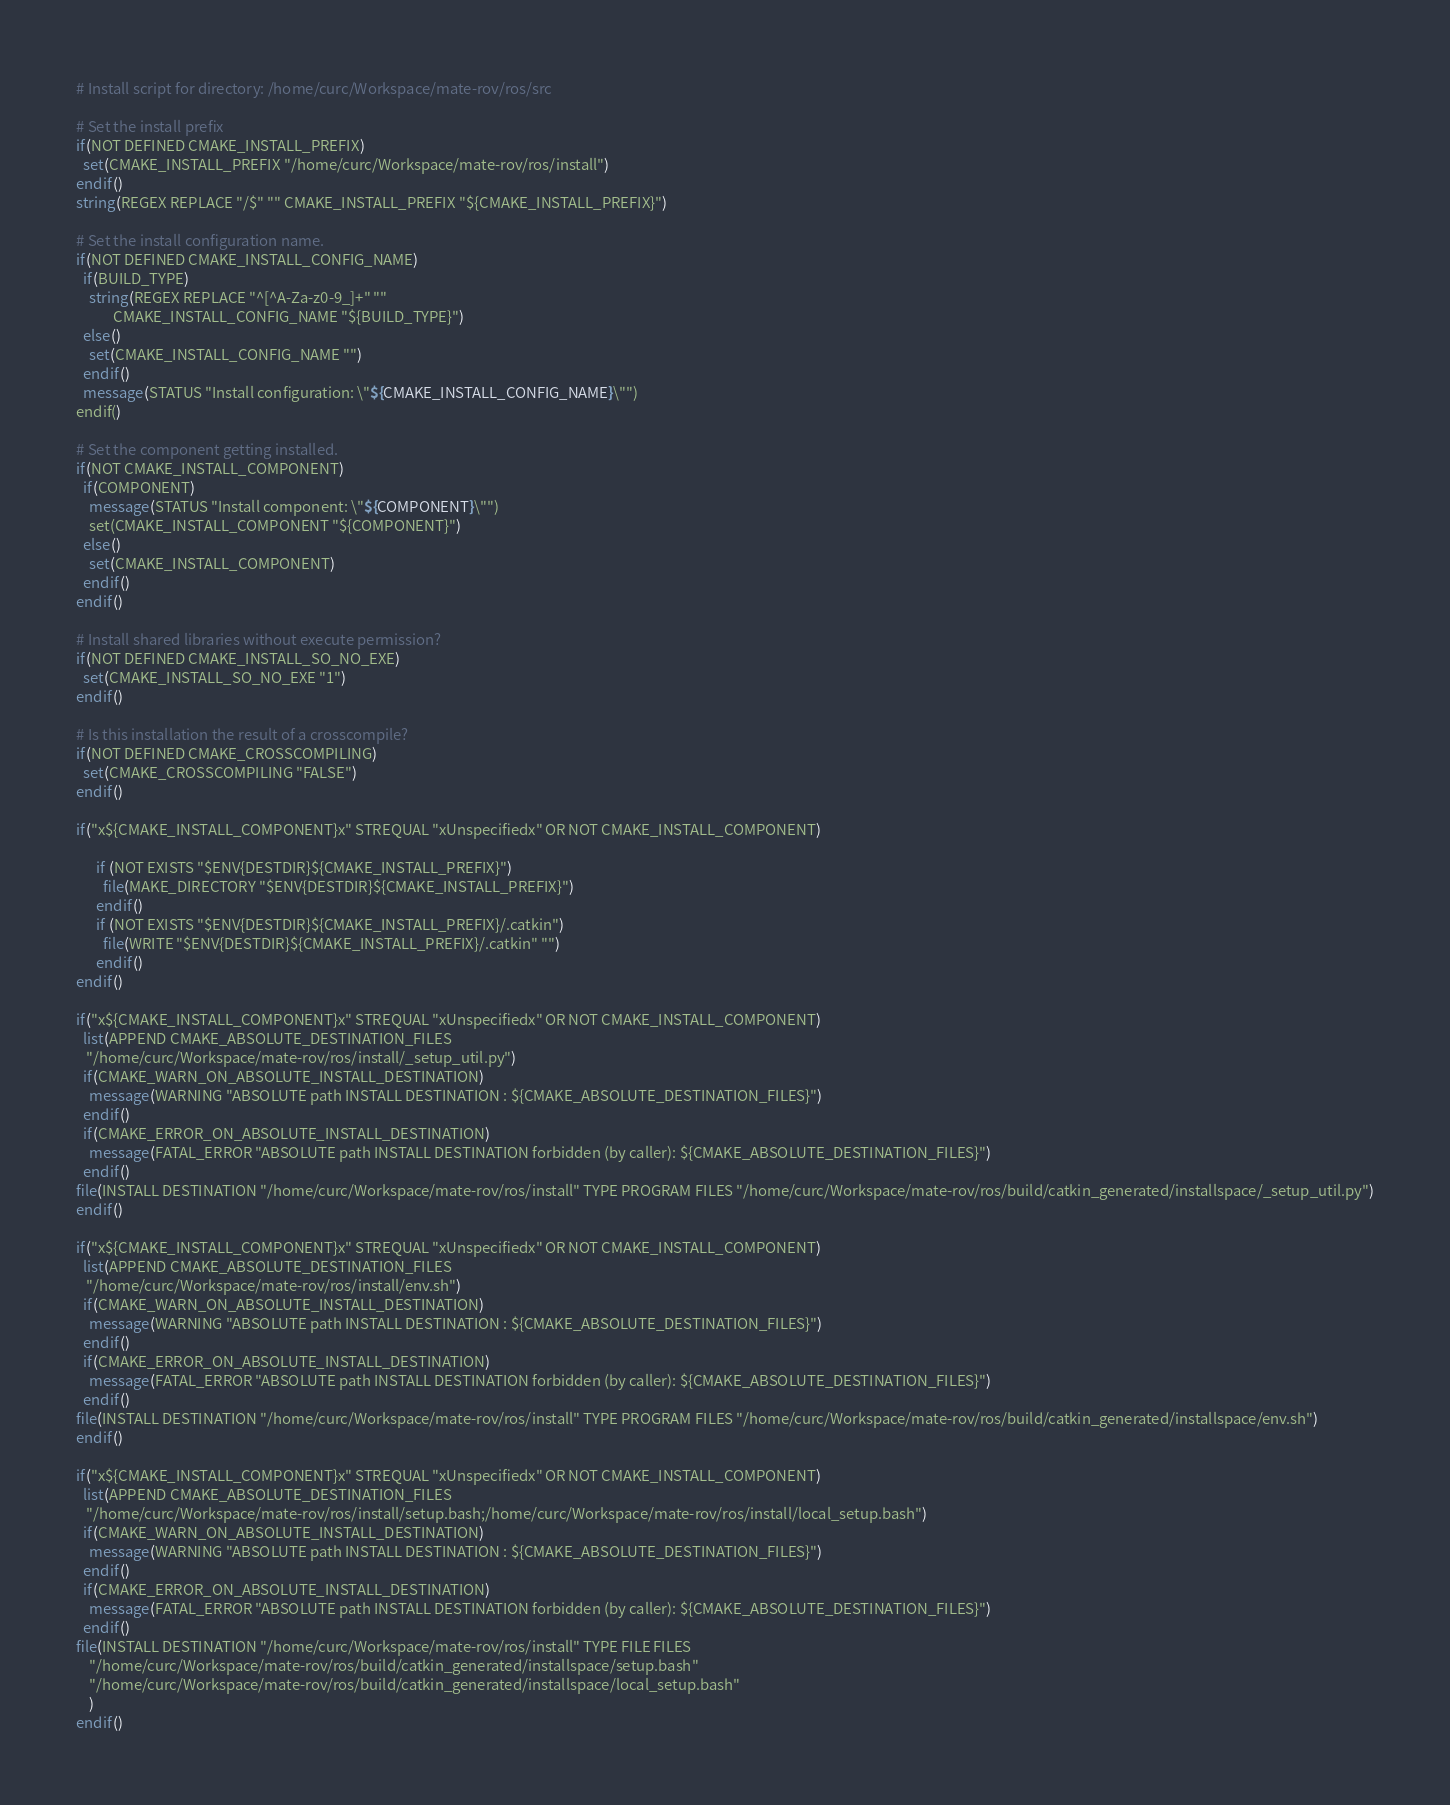<code> <loc_0><loc_0><loc_500><loc_500><_CMake_># Install script for directory: /home/curc/Workspace/mate-rov/ros/src

# Set the install prefix
if(NOT DEFINED CMAKE_INSTALL_PREFIX)
  set(CMAKE_INSTALL_PREFIX "/home/curc/Workspace/mate-rov/ros/install")
endif()
string(REGEX REPLACE "/$" "" CMAKE_INSTALL_PREFIX "${CMAKE_INSTALL_PREFIX}")

# Set the install configuration name.
if(NOT DEFINED CMAKE_INSTALL_CONFIG_NAME)
  if(BUILD_TYPE)
    string(REGEX REPLACE "^[^A-Za-z0-9_]+" ""
           CMAKE_INSTALL_CONFIG_NAME "${BUILD_TYPE}")
  else()
    set(CMAKE_INSTALL_CONFIG_NAME "")
  endif()
  message(STATUS "Install configuration: \"${CMAKE_INSTALL_CONFIG_NAME}\"")
endif()

# Set the component getting installed.
if(NOT CMAKE_INSTALL_COMPONENT)
  if(COMPONENT)
    message(STATUS "Install component: \"${COMPONENT}\"")
    set(CMAKE_INSTALL_COMPONENT "${COMPONENT}")
  else()
    set(CMAKE_INSTALL_COMPONENT)
  endif()
endif()

# Install shared libraries without execute permission?
if(NOT DEFINED CMAKE_INSTALL_SO_NO_EXE)
  set(CMAKE_INSTALL_SO_NO_EXE "1")
endif()

# Is this installation the result of a crosscompile?
if(NOT DEFINED CMAKE_CROSSCOMPILING)
  set(CMAKE_CROSSCOMPILING "FALSE")
endif()

if("x${CMAKE_INSTALL_COMPONENT}x" STREQUAL "xUnspecifiedx" OR NOT CMAKE_INSTALL_COMPONENT)
  
      if (NOT EXISTS "$ENV{DESTDIR}${CMAKE_INSTALL_PREFIX}")
        file(MAKE_DIRECTORY "$ENV{DESTDIR}${CMAKE_INSTALL_PREFIX}")
      endif()
      if (NOT EXISTS "$ENV{DESTDIR}${CMAKE_INSTALL_PREFIX}/.catkin")
        file(WRITE "$ENV{DESTDIR}${CMAKE_INSTALL_PREFIX}/.catkin" "")
      endif()
endif()

if("x${CMAKE_INSTALL_COMPONENT}x" STREQUAL "xUnspecifiedx" OR NOT CMAKE_INSTALL_COMPONENT)
  list(APPEND CMAKE_ABSOLUTE_DESTINATION_FILES
   "/home/curc/Workspace/mate-rov/ros/install/_setup_util.py")
  if(CMAKE_WARN_ON_ABSOLUTE_INSTALL_DESTINATION)
    message(WARNING "ABSOLUTE path INSTALL DESTINATION : ${CMAKE_ABSOLUTE_DESTINATION_FILES}")
  endif()
  if(CMAKE_ERROR_ON_ABSOLUTE_INSTALL_DESTINATION)
    message(FATAL_ERROR "ABSOLUTE path INSTALL DESTINATION forbidden (by caller): ${CMAKE_ABSOLUTE_DESTINATION_FILES}")
  endif()
file(INSTALL DESTINATION "/home/curc/Workspace/mate-rov/ros/install" TYPE PROGRAM FILES "/home/curc/Workspace/mate-rov/ros/build/catkin_generated/installspace/_setup_util.py")
endif()

if("x${CMAKE_INSTALL_COMPONENT}x" STREQUAL "xUnspecifiedx" OR NOT CMAKE_INSTALL_COMPONENT)
  list(APPEND CMAKE_ABSOLUTE_DESTINATION_FILES
   "/home/curc/Workspace/mate-rov/ros/install/env.sh")
  if(CMAKE_WARN_ON_ABSOLUTE_INSTALL_DESTINATION)
    message(WARNING "ABSOLUTE path INSTALL DESTINATION : ${CMAKE_ABSOLUTE_DESTINATION_FILES}")
  endif()
  if(CMAKE_ERROR_ON_ABSOLUTE_INSTALL_DESTINATION)
    message(FATAL_ERROR "ABSOLUTE path INSTALL DESTINATION forbidden (by caller): ${CMAKE_ABSOLUTE_DESTINATION_FILES}")
  endif()
file(INSTALL DESTINATION "/home/curc/Workspace/mate-rov/ros/install" TYPE PROGRAM FILES "/home/curc/Workspace/mate-rov/ros/build/catkin_generated/installspace/env.sh")
endif()

if("x${CMAKE_INSTALL_COMPONENT}x" STREQUAL "xUnspecifiedx" OR NOT CMAKE_INSTALL_COMPONENT)
  list(APPEND CMAKE_ABSOLUTE_DESTINATION_FILES
   "/home/curc/Workspace/mate-rov/ros/install/setup.bash;/home/curc/Workspace/mate-rov/ros/install/local_setup.bash")
  if(CMAKE_WARN_ON_ABSOLUTE_INSTALL_DESTINATION)
    message(WARNING "ABSOLUTE path INSTALL DESTINATION : ${CMAKE_ABSOLUTE_DESTINATION_FILES}")
  endif()
  if(CMAKE_ERROR_ON_ABSOLUTE_INSTALL_DESTINATION)
    message(FATAL_ERROR "ABSOLUTE path INSTALL DESTINATION forbidden (by caller): ${CMAKE_ABSOLUTE_DESTINATION_FILES}")
  endif()
file(INSTALL DESTINATION "/home/curc/Workspace/mate-rov/ros/install" TYPE FILE FILES
    "/home/curc/Workspace/mate-rov/ros/build/catkin_generated/installspace/setup.bash"
    "/home/curc/Workspace/mate-rov/ros/build/catkin_generated/installspace/local_setup.bash"
    )
endif()
</code> 